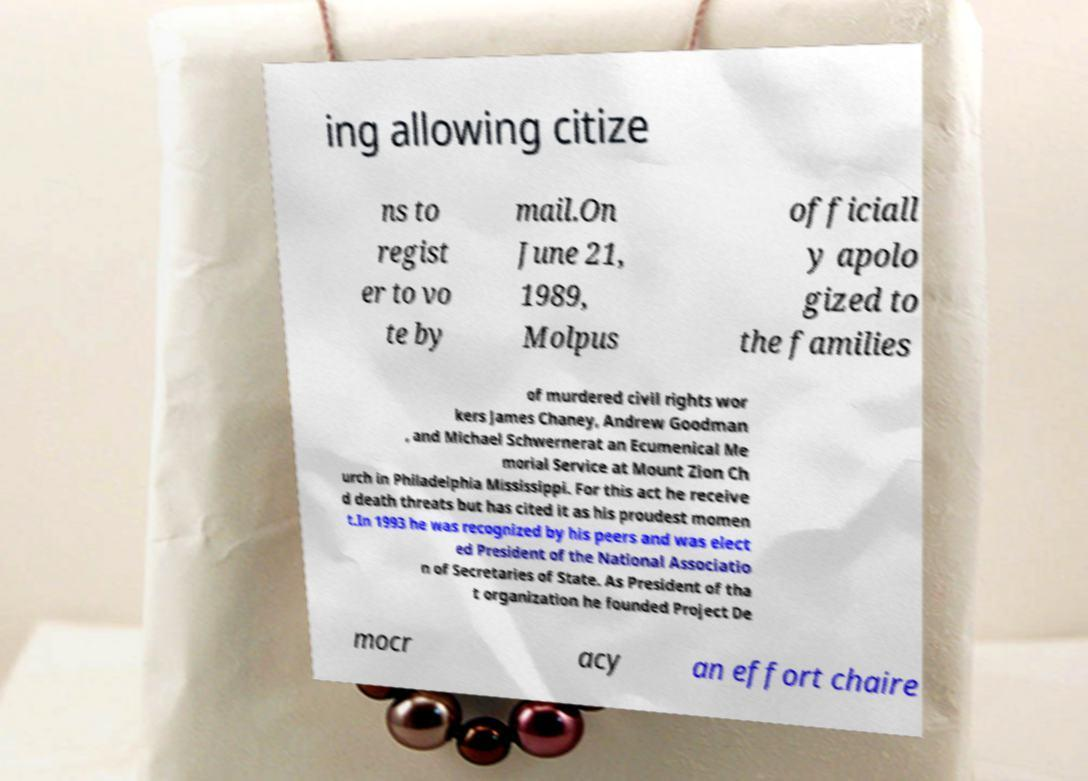For documentation purposes, I need the text within this image transcribed. Could you provide that? ing allowing citize ns to regist er to vo te by mail.On June 21, 1989, Molpus officiall y apolo gized to the families of murdered civil rights wor kers James Chaney, Andrew Goodman , and Michael Schwernerat an Ecumenical Me morial Service at Mount Zion Ch urch in Philadelphia Mississippi. For this act he receive d death threats but has cited it as his proudest momen t.In 1993 he was recognized by his peers and was elect ed President of the National Associatio n of Secretaries of State. As President of tha t organization he founded Project De mocr acy an effort chaire 